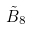<formula> <loc_0><loc_0><loc_500><loc_500>\tilde { B } _ { 8 }</formula> 